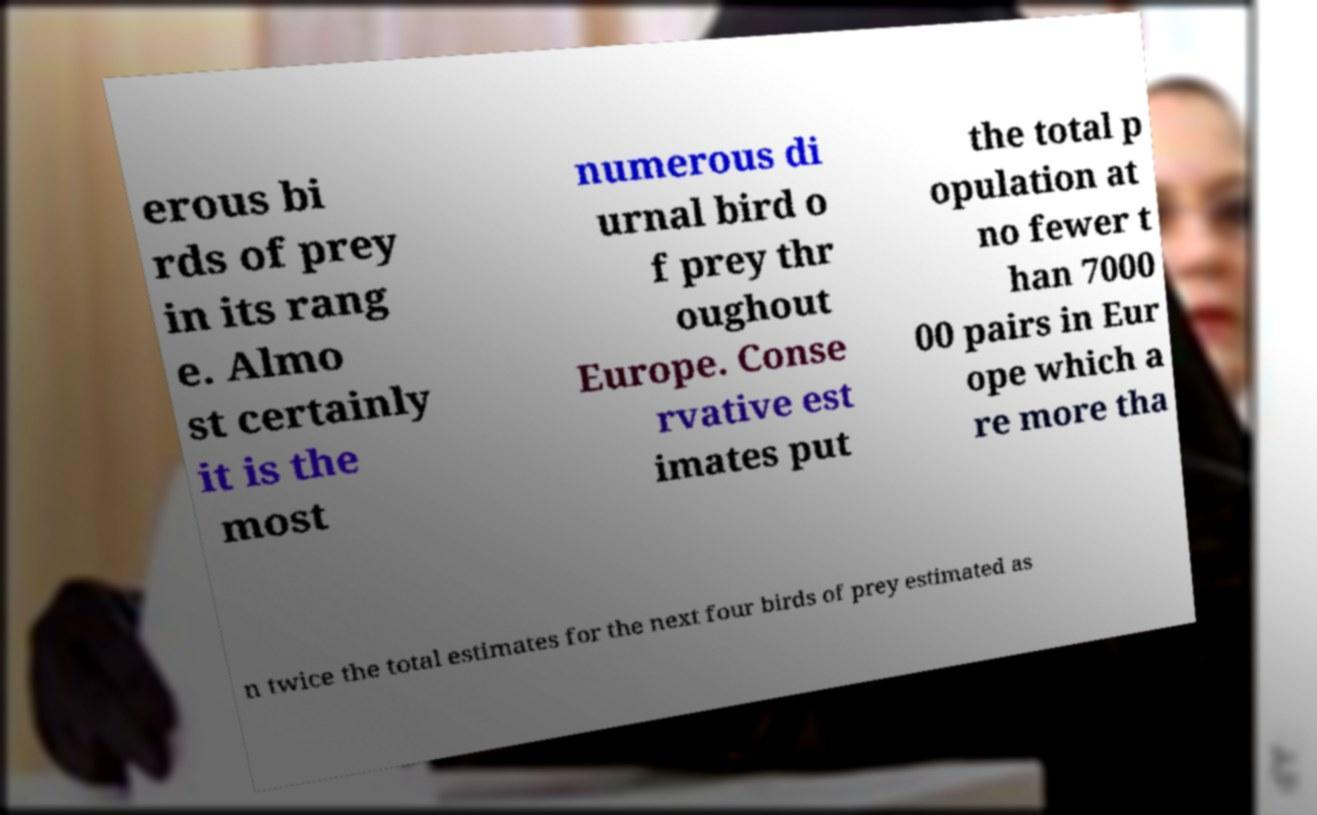Could you assist in decoding the text presented in this image and type it out clearly? erous bi rds of prey in its rang e. Almo st certainly it is the most numerous di urnal bird o f prey thr oughout Europe. Conse rvative est imates put the total p opulation at no fewer t han 7000 00 pairs in Eur ope which a re more tha n twice the total estimates for the next four birds of prey estimated as 